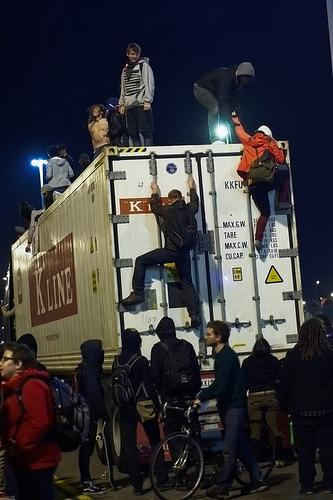Describe a person who stands out in the image due to their appearance. A shirtless man with long hair is standing on top of the truck. What is an unusual place for a group of people to be found in this image? A group of people is standing on top of a truck. Mention an object in the image that's not being used by any person. There's a yellow hazard label with a black triangle and a rectangular sticker next to it. Briefly narrate the scene that includes a man and a bike in the image. A man wearing jeans is holding a bicycle while pushing it through the area. What is a prominent logo or sign seen in the image? A red company logo can be seen on the side of the truck. Identify an unusual accessory that someone has, and describe it. A person with a black shirt is holding a skateboard, along with sporting a book bag. State a unique clothing item worn by one of the individuals in the image. There's a woman in a red jacket wearing a backpack. Choose a man from the image to describe his hair, outfit, and what he is doing. A man with short hair is wearing a black and gray jacket while standing on top of a truck. Mention an interesting action performed by a person in the image. A person in an orange jacket is climbing onto a truck. Describe the clothing of the person with the most vibrant outfit in the image. A girl in an orange jacket is wearing brown pants, engaging in climbing onto a truck. 